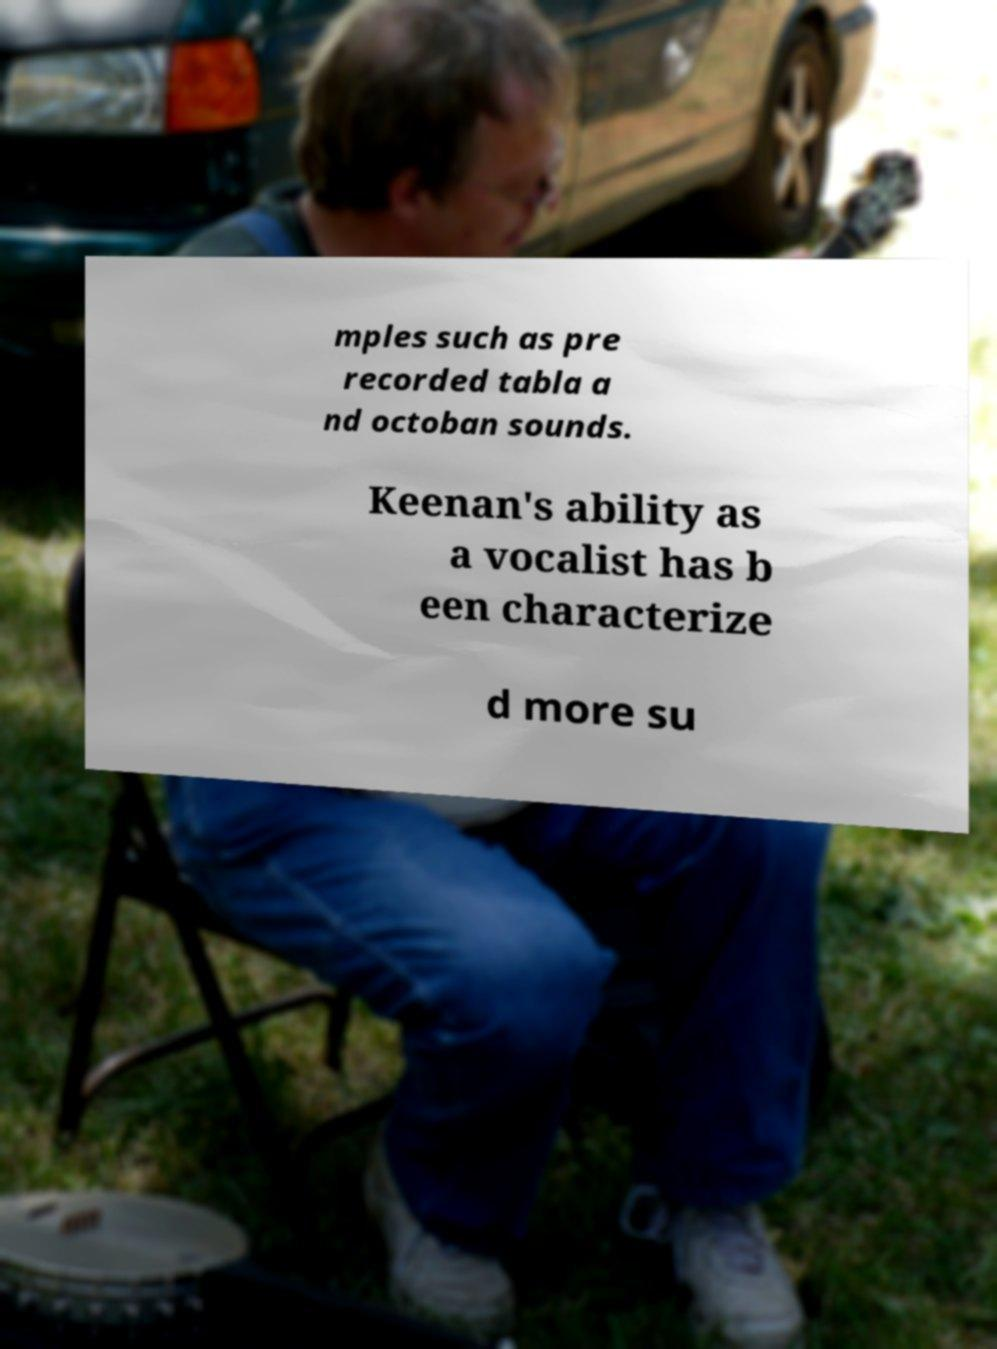For documentation purposes, I need the text within this image transcribed. Could you provide that? mples such as pre recorded tabla a nd octoban sounds. Keenan's ability as a vocalist has b een characterize d more su 